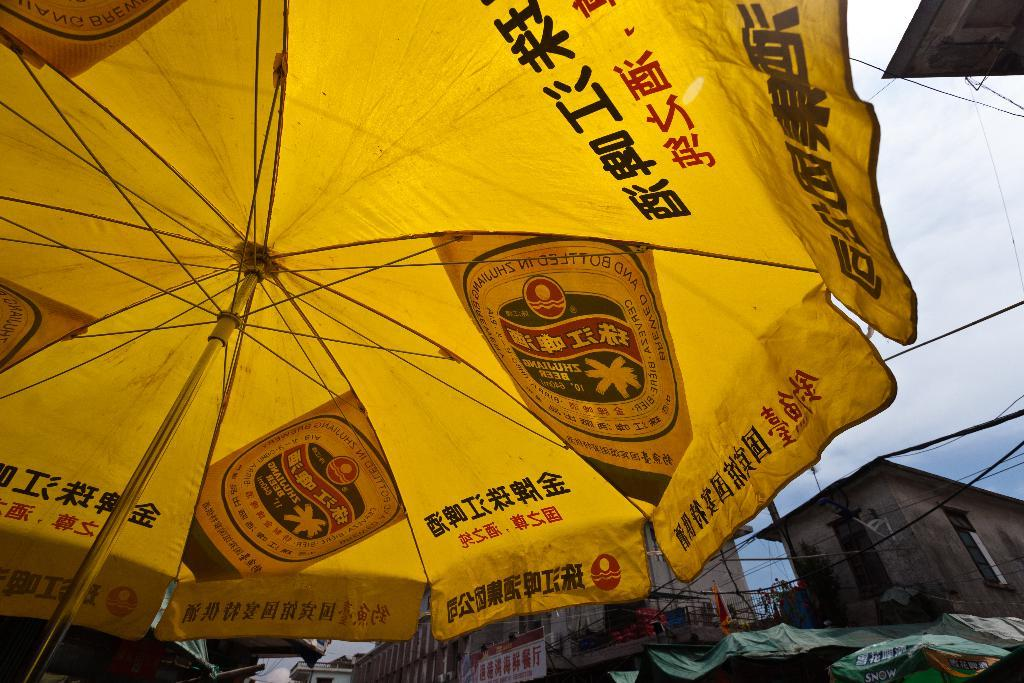What object is present in the image that can provide protection from rain? There is an umbrella in the image. What type of structures can be seen in the image? There are buildings in the image. What architectural feature is visible in the image? There is a wall in the image. What type of utility infrastructure can be seen in the image? There are wires in the image. What type of signage is present in the image? There is a banner in the image. What is visible in the sky in the image? The sky is visible in the image, and there are clouds in the sky. What type of advice is being given on the banner in the image? There is no advice present on the banner in the image; it is simply a banner. What type of crime is being committed in the image? There is no crime present in the image; it is a scene with an umbrella, buildings, a wall, wires, a banner, and the sky. 